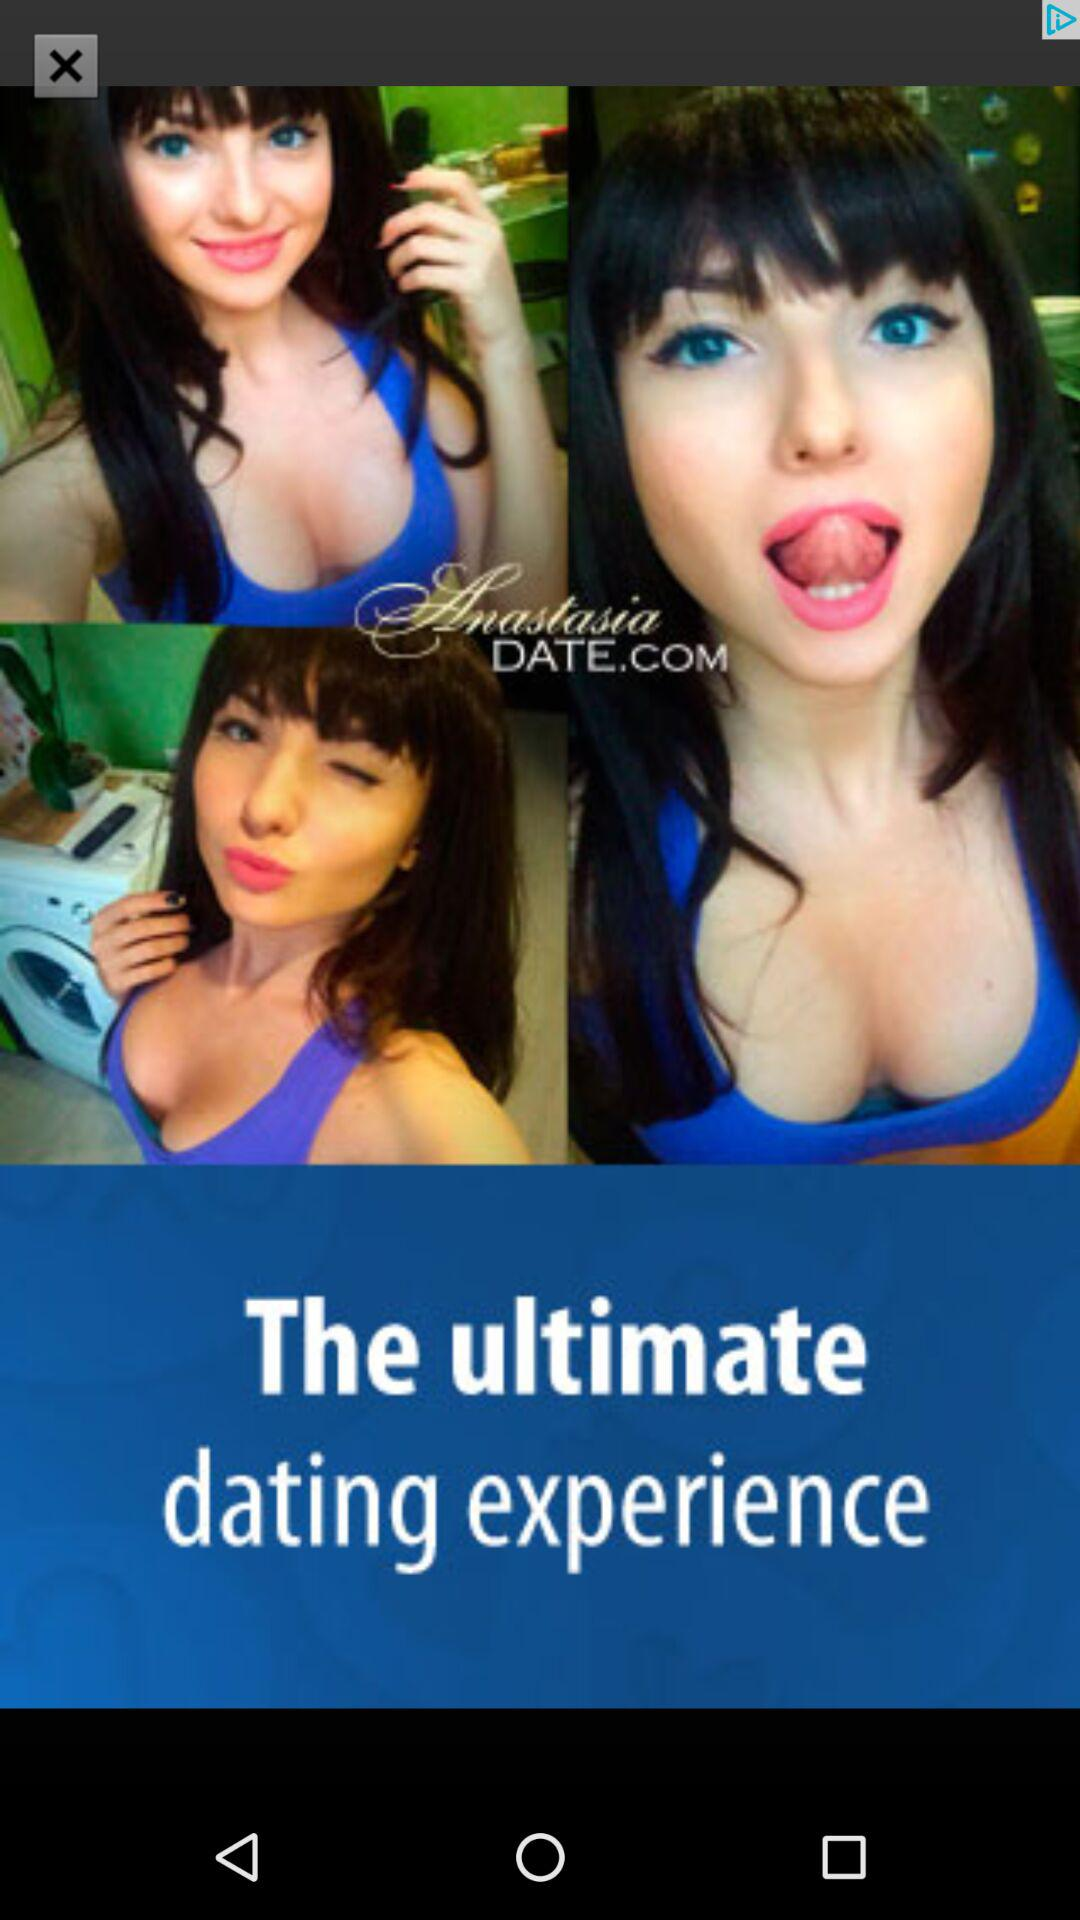What is the application name? The application name is "Anastasia Date". 